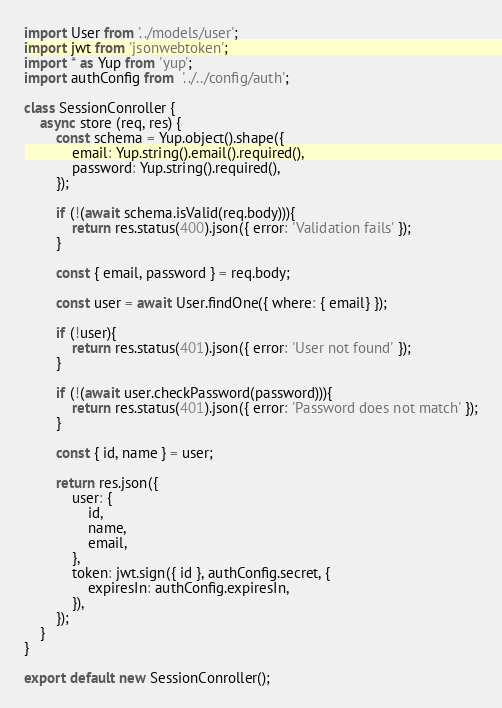<code> <loc_0><loc_0><loc_500><loc_500><_JavaScript_>import User from '../models/user';
import jwt from 'jsonwebtoken';
import * as Yup from 'yup';
import authConfig from  '../../config/auth';

class SessionConroller {
    async store (req, res) {
        const schema = Yup.object().shape({
            email: Yup.string().email().required(),
            password: Yup.string().required(),
        });

        if (!(await schema.isValid(req.body))){
            return res.status(400).json({ error: 'Validation fails' });
        }

        const { email, password } = req.body;

        const user = await User.findOne({ where: { email} });

        if (!user){
            return res.status(401).json({ error: 'User not found' });
        }

        if (!(await user.checkPassword(password))){
            return res.status(401).json({ error: 'Password does not match' });
        }

        const { id, name } = user;

        return res.json({
            user: {
                id,
                name,
                email,
            },
            token: jwt.sign({ id }, authConfig.secret, {
                expiresIn: authConfig.expiresIn,
            }),
        });
    }
}

export default new SessionConroller();</code> 